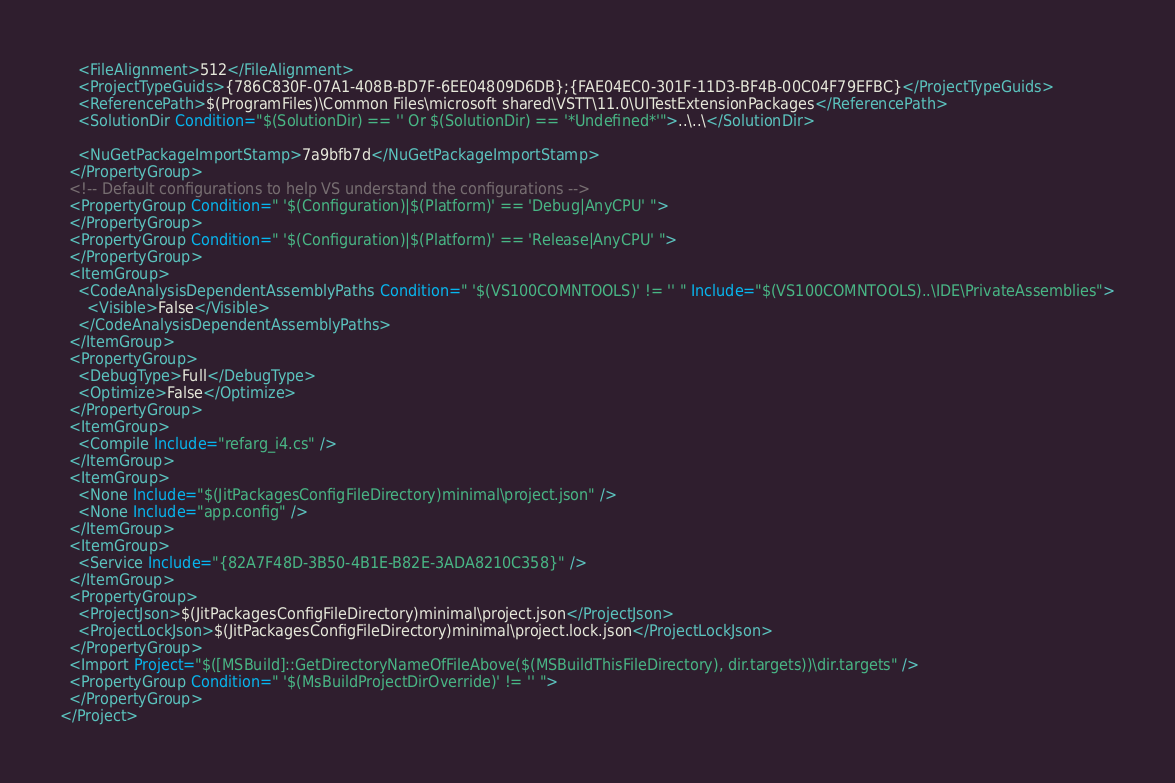<code> <loc_0><loc_0><loc_500><loc_500><_XML_>    <FileAlignment>512</FileAlignment>
    <ProjectTypeGuids>{786C830F-07A1-408B-BD7F-6EE04809D6DB};{FAE04EC0-301F-11D3-BF4B-00C04F79EFBC}</ProjectTypeGuids>
    <ReferencePath>$(ProgramFiles)\Common Files\microsoft shared\VSTT\11.0\UITestExtensionPackages</ReferencePath>
    <SolutionDir Condition="$(SolutionDir) == '' Or $(SolutionDir) == '*Undefined*'">..\..\</SolutionDir>

    <NuGetPackageImportStamp>7a9bfb7d</NuGetPackageImportStamp>
  </PropertyGroup>
  <!-- Default configurations to help VS understand the configurations -->
  <PropertyGroup Condition=" '$(Configuration)|$(Platform)' == 'Debug|AnyCPU' ">
  </PropertyGroup>
  <PropertyGroup Condition=" '$(Configuration)|$(Platform)' == 'Release|AnyCPU' ">
  </PropertyGroup>
  <ItemGroup>
    <CodeAnalysisDependentAssemblyPaths Condition=" '$(VS100COMNTOOLS)' != '' " Include="$(VS100COMNTOOLS)..\IDE\PrivateAssemblies">
      <Visible>False</Visible>
    </CodeAnalysisDependentAssemblyPaths>
  </ItemGroup>
  <PropertyGroup>
    <DebugType>Full</DebugType>
    <Optimize>False</Optimize>
  </PropertyGroup>
  <ItemGroup>
    <Compile Include="refarg_i4.cs" />
  </ItemGroup>
  <ItemGroup>
    <None Include="$(JitPackagesConfigFileDirectory)minimal\project.json" />
    <None Include="app.config" />
  </ItemGroup>
  <ItemGroup>
    <Service Include="{82A7F48D-3B50-4B1E-B82E-3ADA8210C358}" />
  </ItemGroup>
  <PropertyGroup>
    <ProjectJson>$(JitPackagesConfigFileDirectory)minimal\project.json</ProjectJson>
    <ProjectLockJson>$(JitPackagesConfigFileDirectory)minimal\project.lock.json</ProjectLockJson>
  </PropertyGroup>
  <Import Project="$([MSBuild]::GetDirectoryNameOfFileAbove($(MSBuildThisFileDirectory), dir.targets))\dir.targets" />
  <PropertyGroup Condition=" '$(MsBuildProjectDirOverride)' != '' ">
  </PropertyGroup> 
</Project>
</code> 